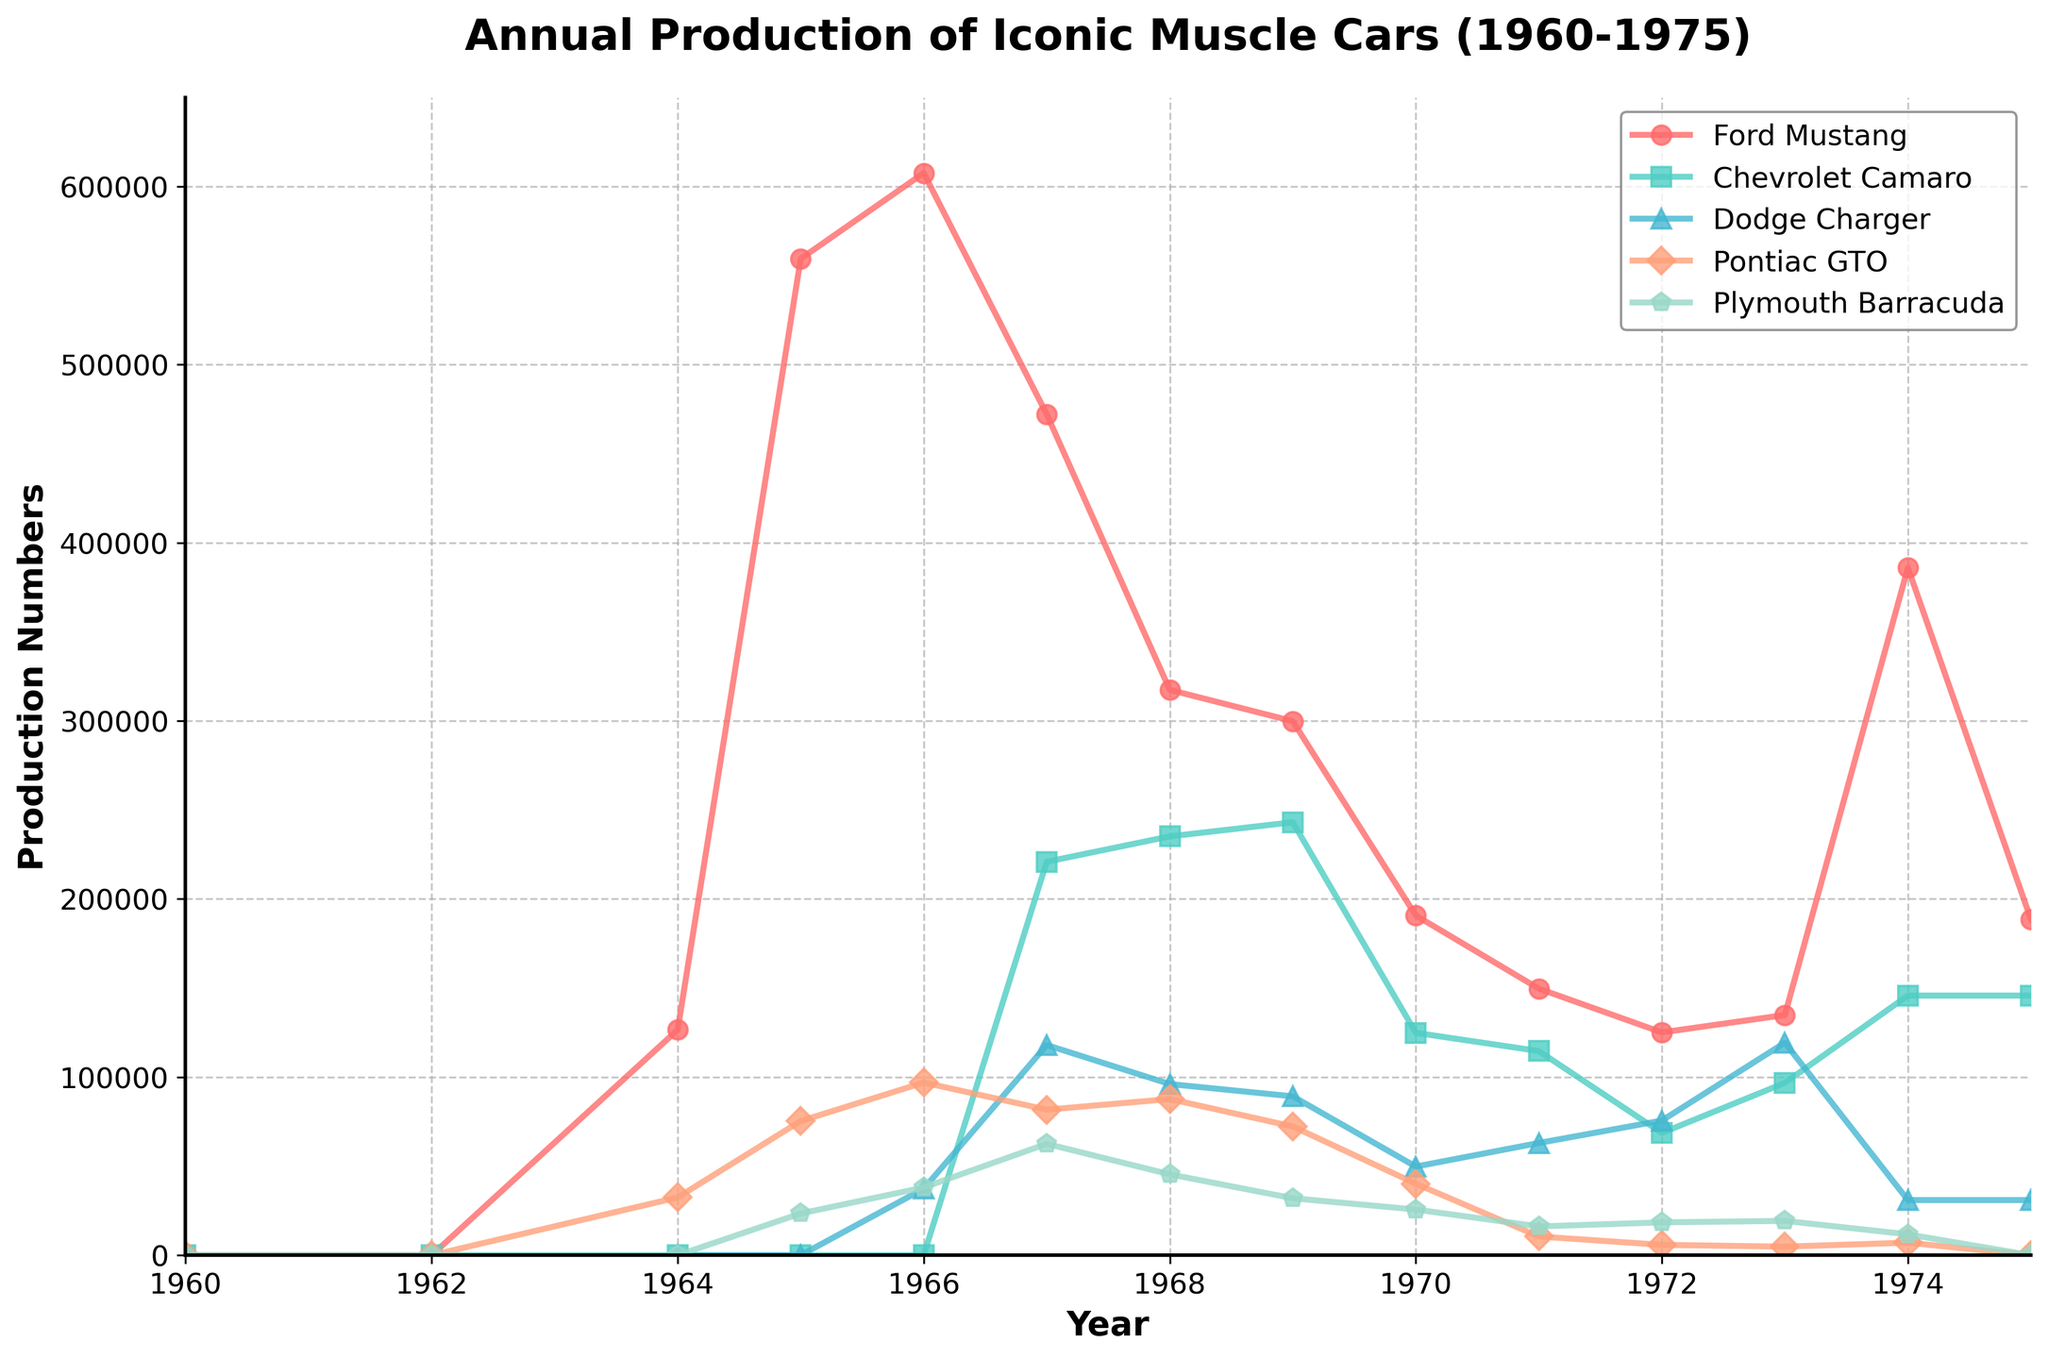What was the highest annual production number for the Ford Mustang, and in what year did it occur? Look at the Ford Mustang line to find the peak production year. The highest point is 559451 units, which occurred in 1965.
Answer: 559451 units in 1965 Which car had the highest production numbers in 1973? Check the height of the lines corresponding to each car for the year 1973. The tallest line represents the Dodge Charger with 119318 units.
Answer: Dodge Charger Which of the vehicles experienced the most consistent decline in production from 1965 to 1971? Examine the slope of the lines for each car from 1965 to 1971. The Pontiac GTO line consistently slopes downward without any increases.
Answer: Pontiac GTO In 1969, which model had more production: the Dodge Charger or the Chevrolet Camaro? Compare the values of the Dodge Charger and Chevrolet Camaro for 1969. The Dodge Charger had 89199 units, whereas the Chevrolet Camaro had 243085 units.
Answer: Chevrolet Camaro What is the total production sum for the Plymouth Barracuda from 1964 to 1975? Sum up the annual production numbers for the Plymouth Barracuda from the data for the years it was produced. The total is 23443 + 38029 + 62534 + 45412 + 31987 + 25651 + 16159 + 18450 + 19281 + 11734 = 292680.
Answer: 292680 units Between which consecutive years did the Ford Mustang experience the greatest drop in production? Look for the largest difference between consecutive years in the Ford Mustang data. The biggest drop is from 1966 to 1967, from 607568 to 472121, a decrease of 135447 units.
Answer: 1966 to 1967 Which two cars had zero production in both 1960 and 1962? Identify the cars with zero production numbers in both 1960 and 1962 by verifying each column's data for those years. Both the Chevrolet Camaro and the Dodge Charger had zero production in these years.
Answer: Chevrolet Camaro and Dodge Charger What was the general trend in the production of the Pontiac GTO from 1964 to 1975? Observe the overall pattern in the Pontiac GTO line from 1964 to 1975. The production mostly declined with a significant drop around 1971 and then remained low.
Answer: General decline During which year did the production numbers for the Plymouth Barracuda peak, and how many units were produced? Find the highest point in the Plymouth Barracuda line. The peak occurred in 1967 with 62534 units produced.
Answer: 1967, 62534 units 